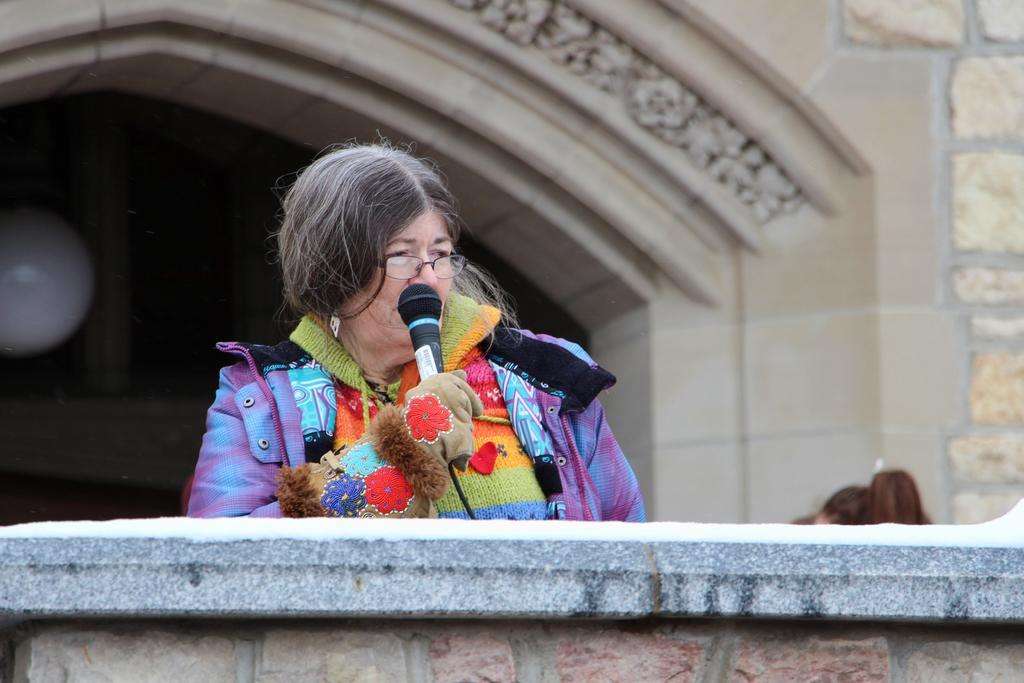Please provide a concise description of this image. In this picture we can see a woman with spectacles and she is holding a microphone with a cable. In front of the woman, there is a wall. Behind the woman, there is a building, a round shape object and a dark background. 